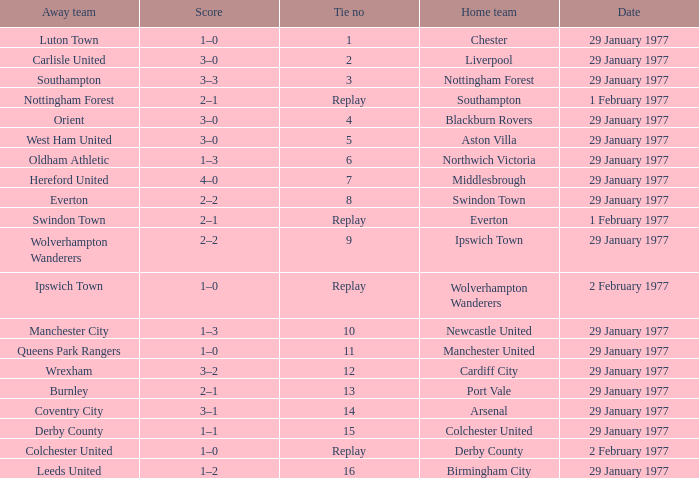Which away team has a tie number of 3? Southampton. 